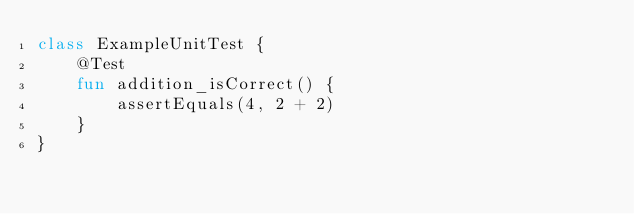Convert code to text. <code><loc_0><loc_0><loc_500><loc_500><_Kotlin_>class ExampleUnitTest {
    @Test
    fun addition_isCorrect() {
        assertEquals(4, 2 + 2)
    }
}</code> 